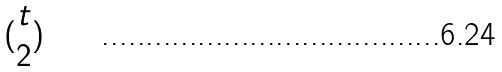<formula> <loc_0><loc_0><loc_500><loc_500>( \begin{matrix} t \\ 2 \end{matrix} )</formula> 